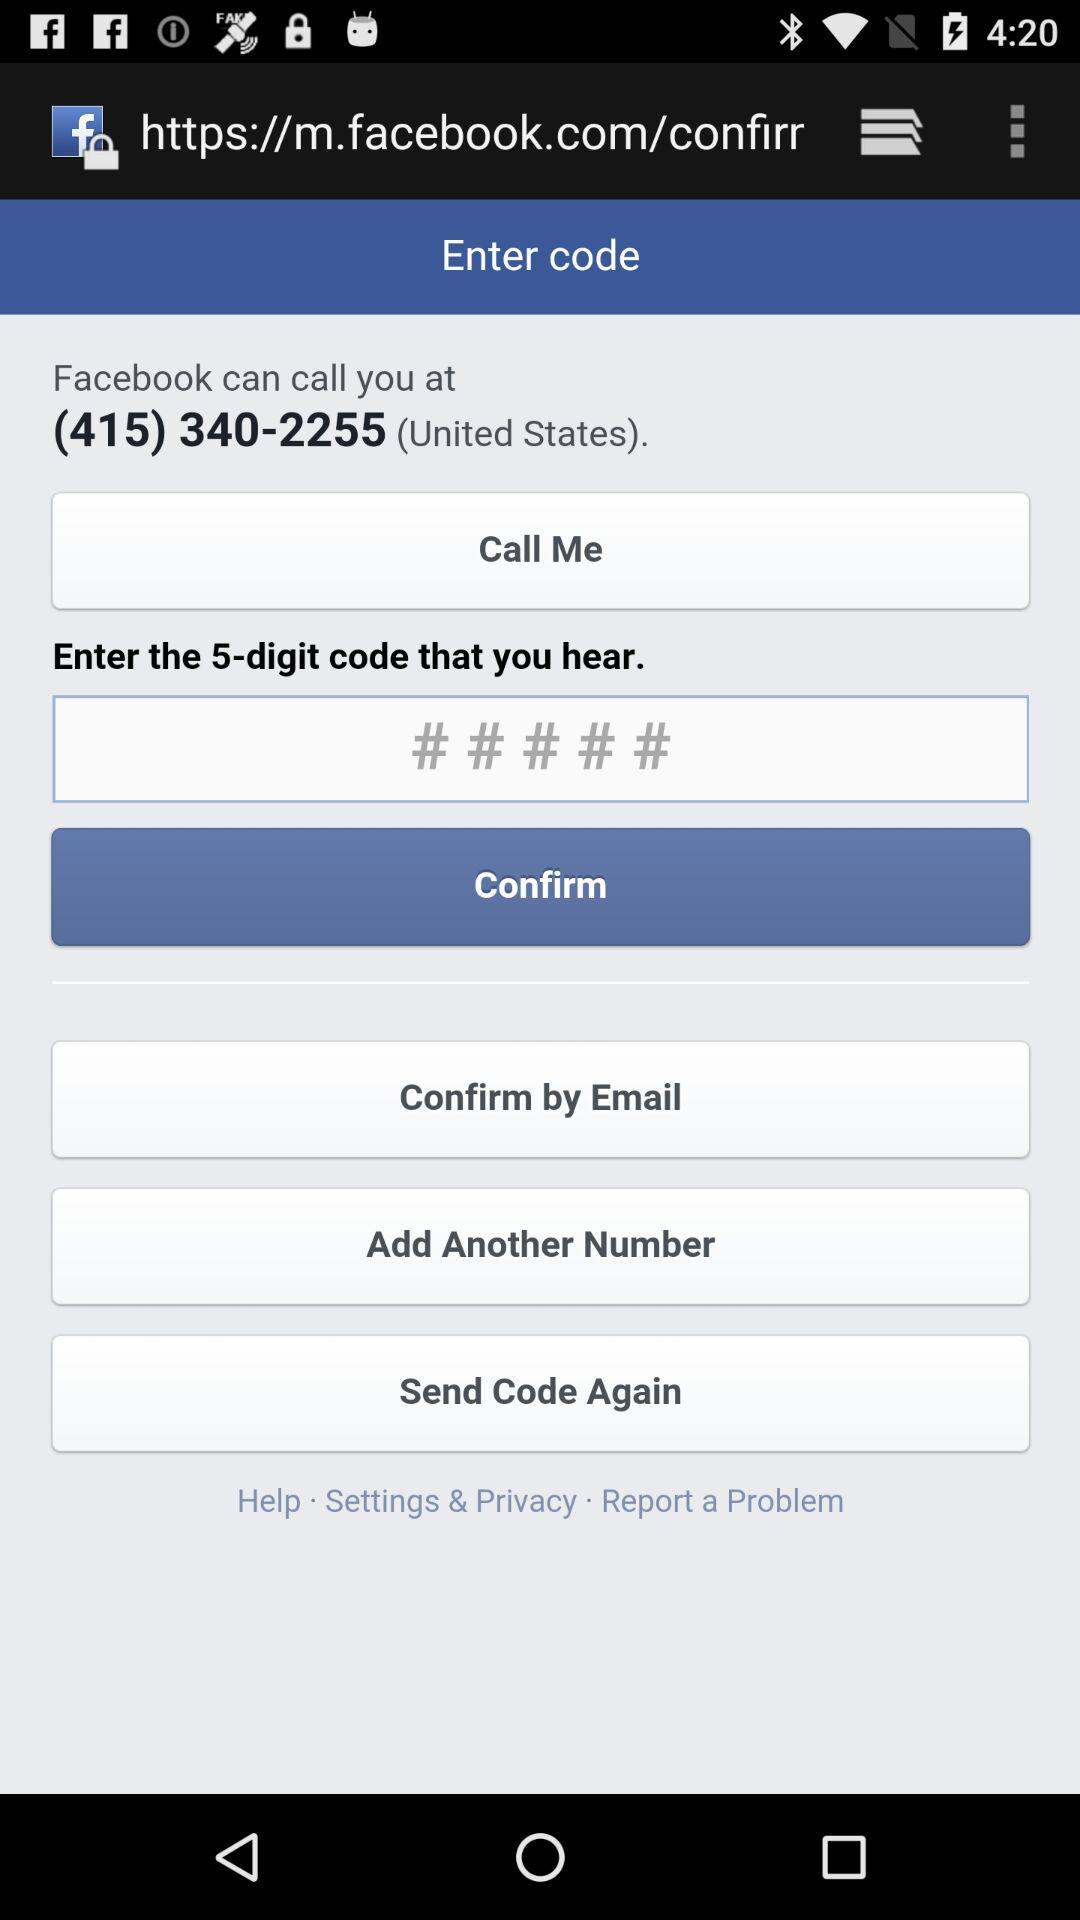How many digits are there in the code?
Answer the question using a single word or phrase. 5 